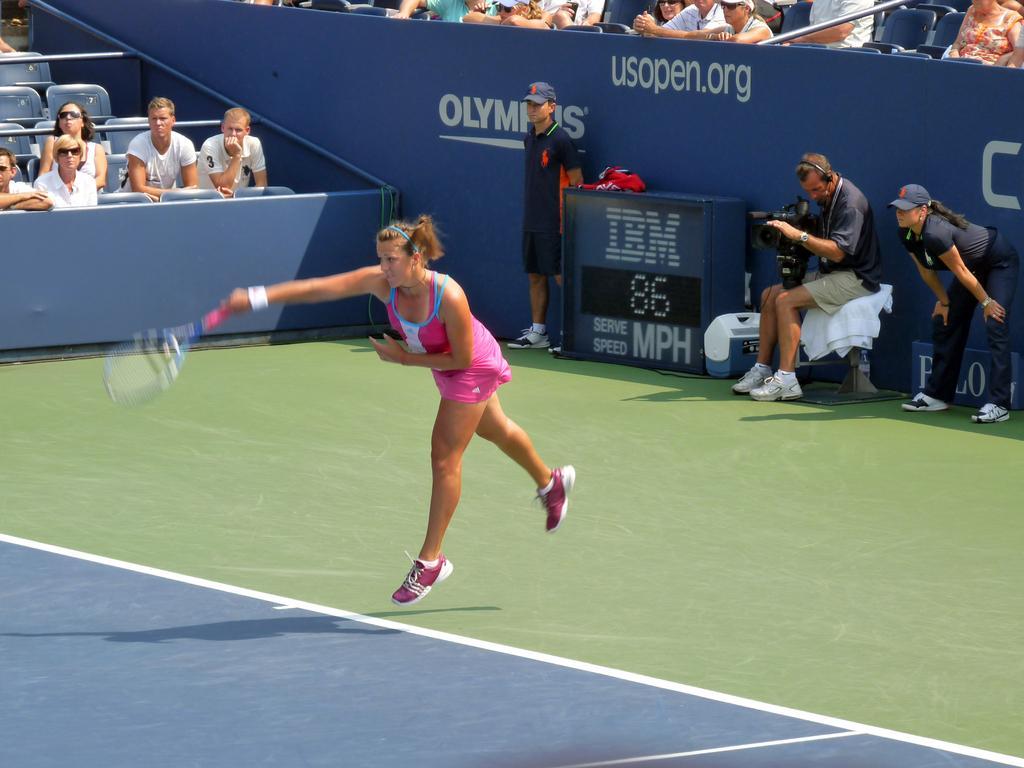Describe this image in one or two sentences. In the image we can see there is woman who is standing and holding tennis racket in her hand and behind her there are men who are sitting and standing and a man is taking video of the woman and beside there are people who are looking at the woman. 